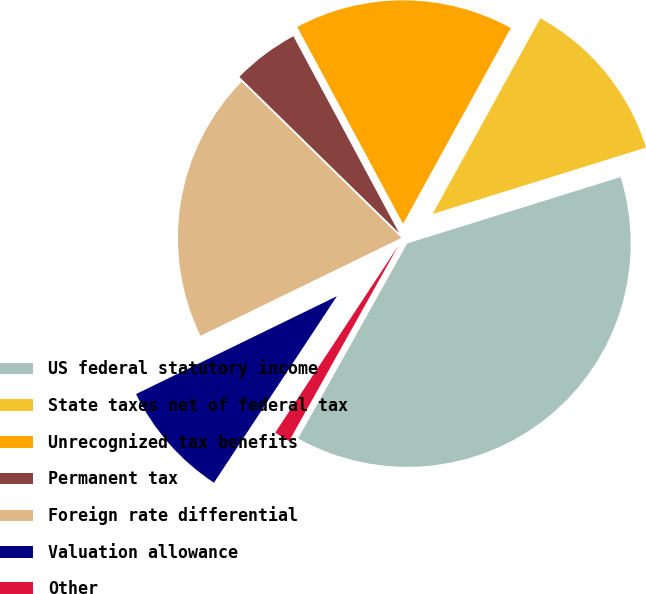Convert chart. <chart><loc_0><loc_0><loc_500><loc_500><pie_chart><fcel>US federal statutory income<fcel>State taxes net of federal tax<fcel>Unrecognized tax benefits<fcel>Permanent tax<fcel>Foreign rate differential<fcel>Valuation allowance<fcel>Other<nl><fcel>37.92%<fcel>12.19%<fcel>15.86%<fcel>4.83%<fcel>19.54%<fcel>8.51%<fcel>1.16%<nl></chart> 